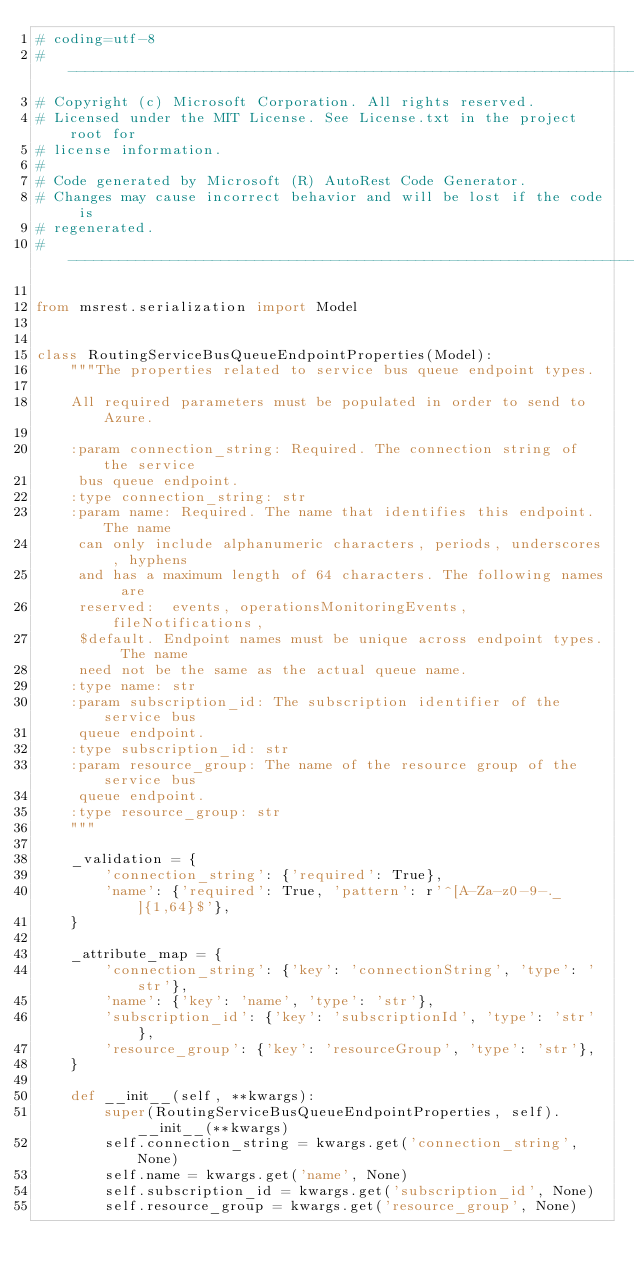<code> <loc_0><loc_0><loc_500><loc_500><_Python_># coding=utf-8
# --------------------------------------------------------------------------
# Copyright (c) Microsoft Corporation. All rights reserved.
# Licensed under the MIT License. See License.txt in the project root for
# license information.
#
# Code generated by Microsoft (R) AutoRest Code Generator.
# Changes may cause incorrect behavior and will be lost if the code is
# regenerated.
# --------------------------------------------------------------------------

from msrest.serialization import Model


class RoutingServiceBusQueueEndpointProperties(Model):
    """The properties related to service bus queue endpoint types.

    All required parameters must be populated in order to send to Azure.

    :param connection_string: Required. The connection string of the service
     bus queue endpoint.
    :type connection_string: str
    :param name: Required. The name that identifies this endpoint. The name
     can only include alphanumeric characters, periods, underscores, hyphens
     and has a maximum length of 64 characters. The following names are
     reserved:  events, operationsMonitoringEvents, fileNotifications,
     $default. Endpoint names must be unique across endpoint types. The name
     need not be the same as the actual queue name.
    :type name: str
    :param subscription_id: The subscription identifier of the service bus
     queue endpoint.
    :type subscription_id: str
    :param resource_group: The name of the resource group of the service bus
     queue endpoint.
    :type resource_group: str
    """

    _validation = {
        'connection_string': {'required': True},
        'name': {'required': True, 'pattern': r'^[A-Za-z0-9-._]{1,64}$'},
    }

    _attribute_map = {
        'connection_string': {'key': 'connectionString', 'type': 'str'},
        'name': {'key': 'name', 'type': 'str'},
        'subscription_id': {'key': 'subscriptionId', 'type': 'str'},
        'resource_group': {'key': 'resourceGroup', 'type': 'str'},
    }

    def __init__(self, **kwargs):
        super(RoutingServiceBusQueueEndpointProperties, self).__init__(**kwargs)
        self.connection_string = kwargs.get('connection_string', None)
        self.name = kwargs.get('name', None)
        self.subscription_id = kwargs.get('subscription_id', None)
        self.resource_group = kwargs.get('resource_group', None)
</code> 